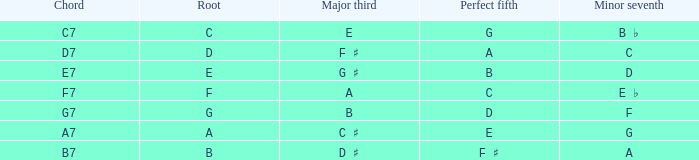What is the Chord with a Minor that is seventh of f? G7. 